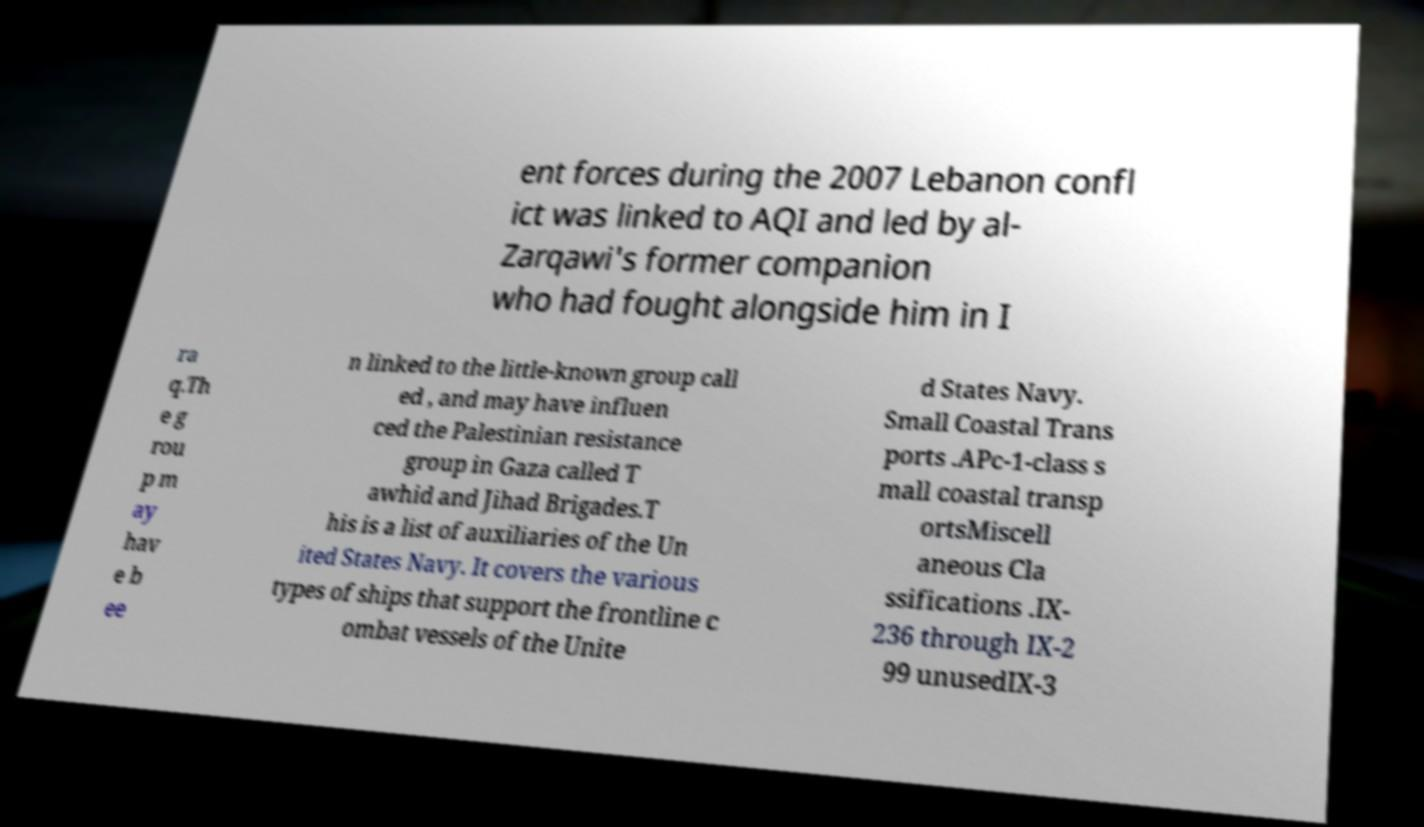Could you assist in decoding the text presented in this image and type it out clearly? ent forces during the 2007 Lebanon confl ict was linked to AQI and led by al- Zarqawi's former companion who had fought alongside him in I ra q.Th e g rou p m ay hav e b ee n linked to the little-known group call ed , and may have influen ced the Palestinian resistance group in Gaza called T awhid and Jihad Brigades.T his is a list of auxiliaries of the Un ited States Navy. It covers the various types of ships that support the frontline c ombat vessels of the Unite d States Navy. Small Coastal Trans ports .APc-1-class s mall coastal transp ortsMiscell aneous Cla ssifications .IX- 236 through IX-2 99 unusedIX-3 